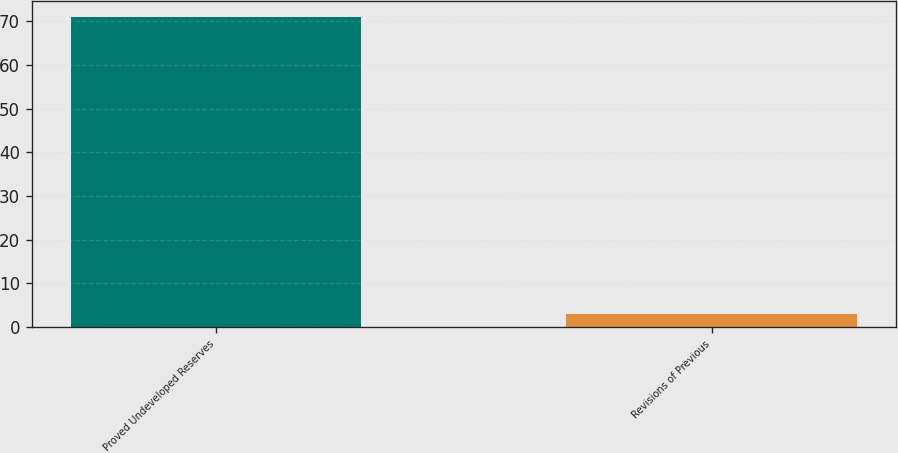<chart> <loc_0><loc_0><loc_500><loc_500><bar_chart><fcel>Proved Undeveloped Reserves<fcel>Revisions of Previous<nl><fcel>71<fcel>3<nl></chart> 